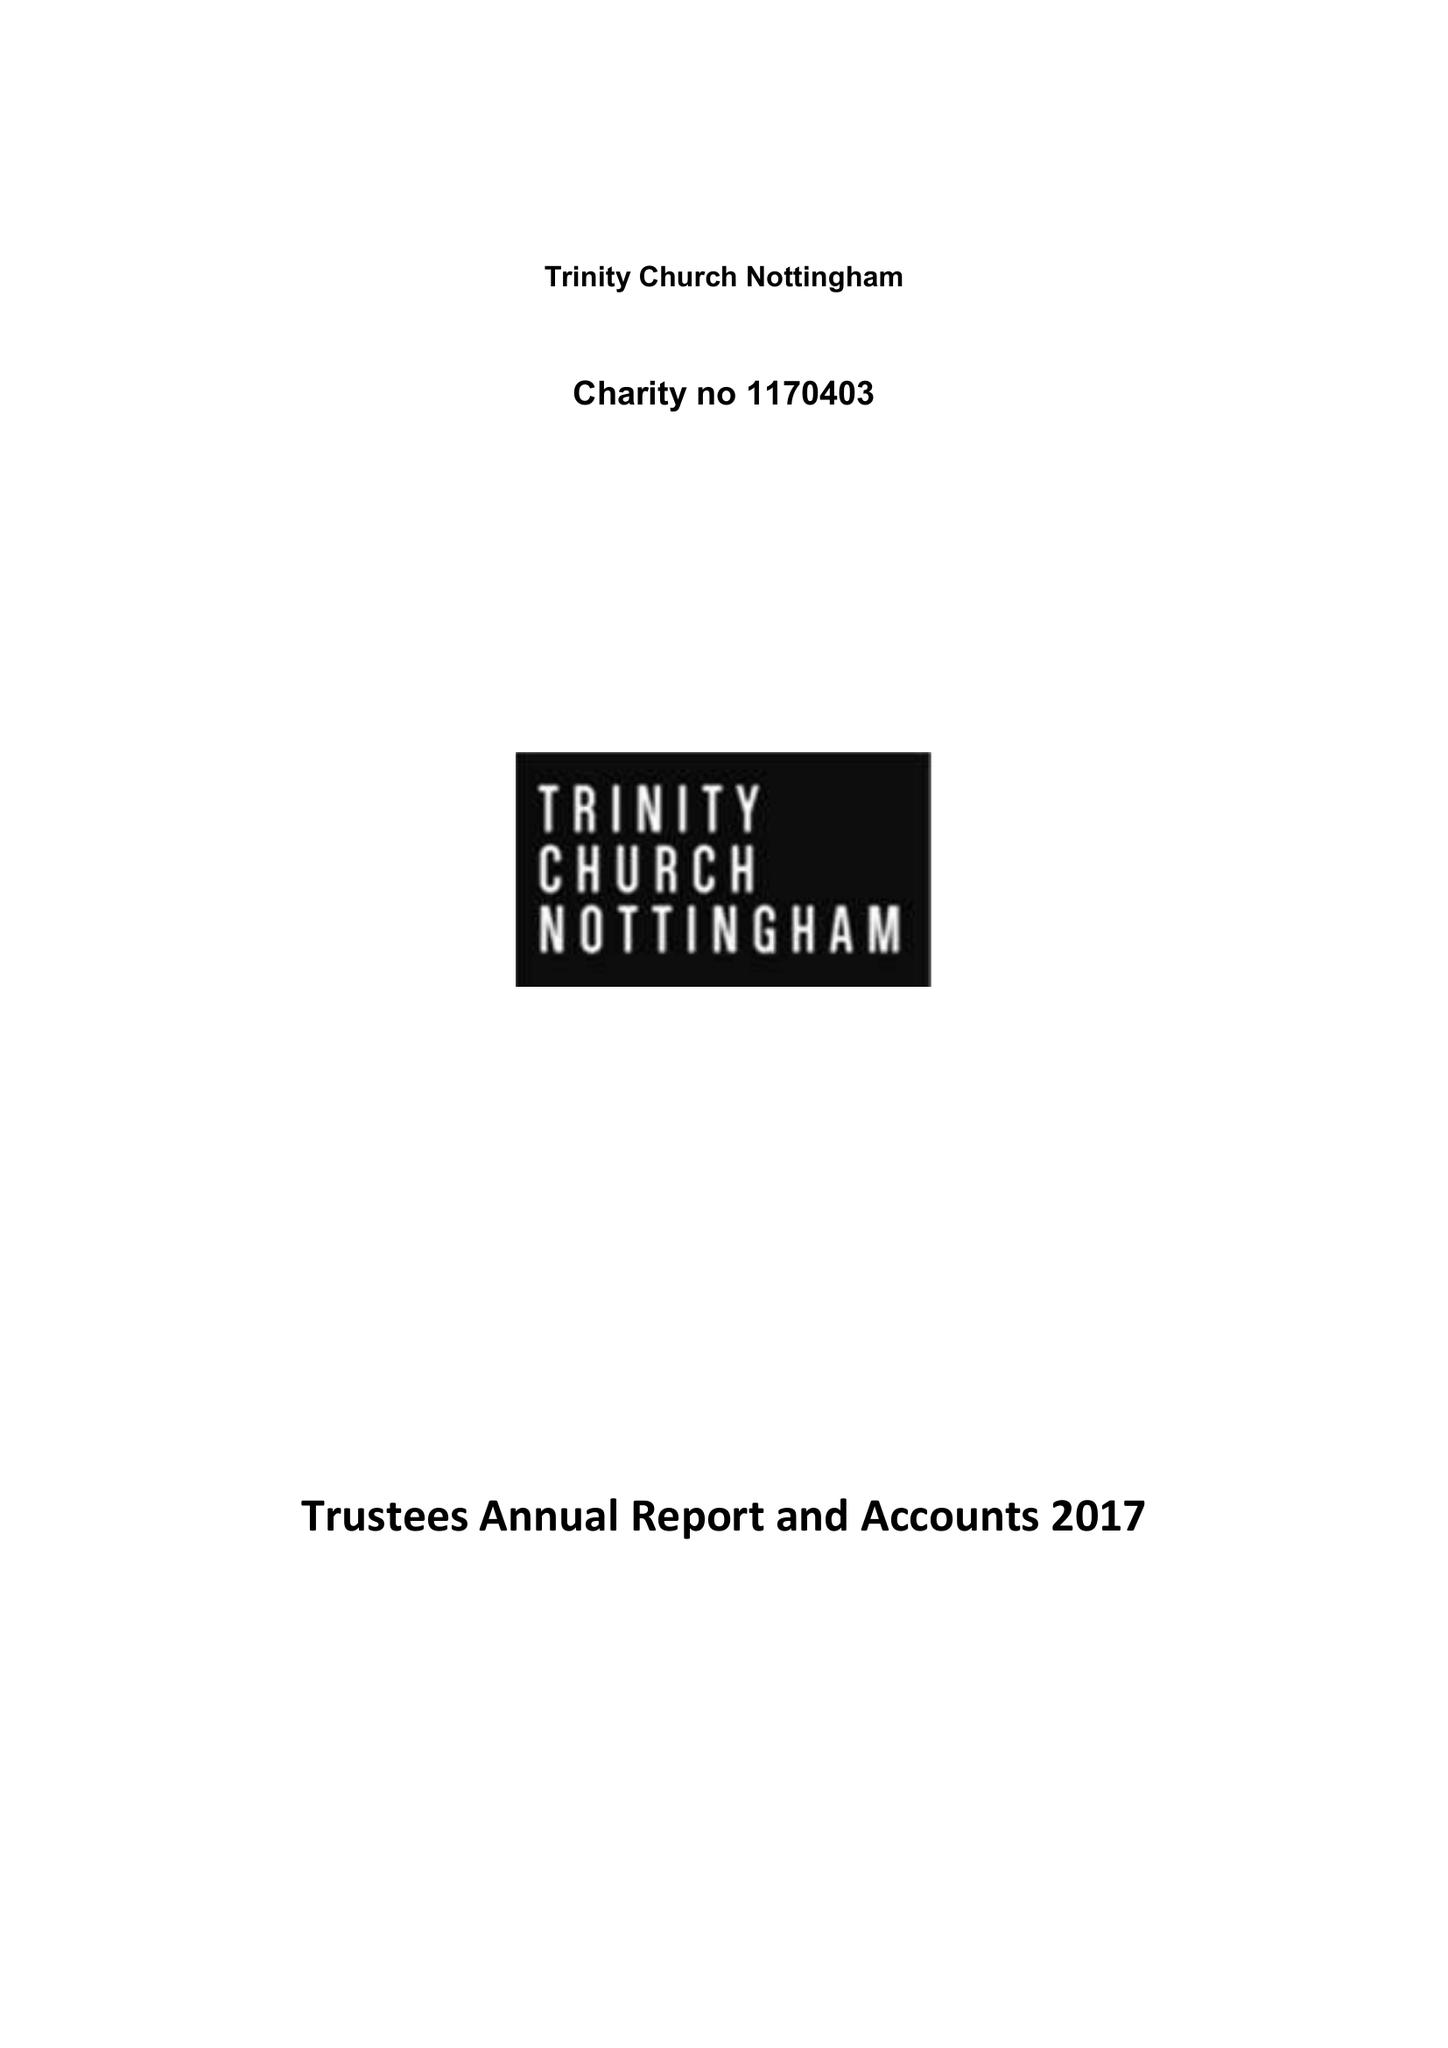What is the value for the income_annually_in_british_pounds?
Answer the question using a single word or phrase. 241393.00 